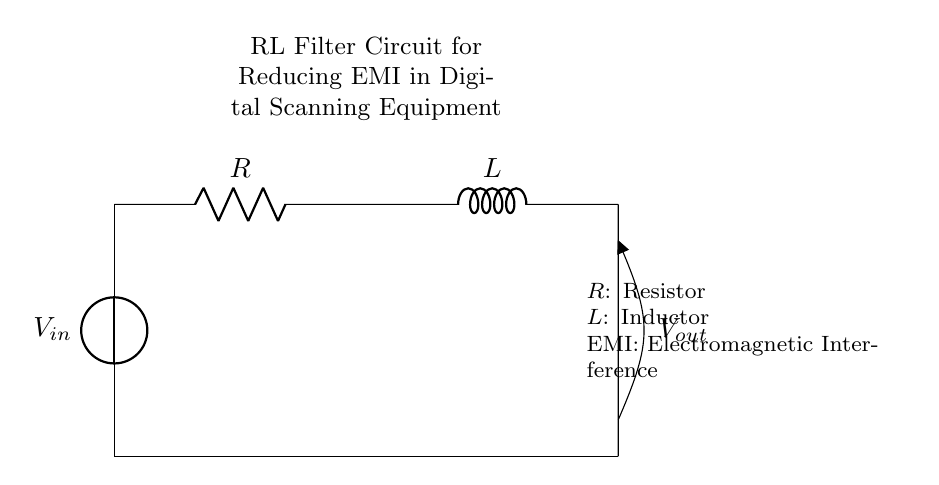What components are present in the circuit? The circuit contains a voltage source, a resistor, and an inductor. These components are essential for the operation of the RL filter.
Answer: Voltage source, resistor, inductor What is the function of the inductor in this circuit? The inductor's primary function is to oppose changes in current, thus helping to filter out high-frequency noise or electromagnetic interference.
Answer: Filter EMI What is the value of the resistance denoted in the circuit? The circuit specifies a resistor labeled as R, indicating it is the resistance component but does not provide a numerical value.
Answer: R What type of circuit is represented by the combination of components here? The combination of a resistor and an inductor in series forms an RL filter circuit, which is specifically designed for signal processing applications.
Answer: RL filter circuit How does the RL filter affect the output voltage compared to the input voltage? The RL filter attenuates high-frequency components, resulting in an output voltage that is lower than the input voltage for these frequencies.
Answer: Output voltage lower than input What happens to current in the circuit when switching occurs? When switching occurs, the inductor resists changes in current flow, causing a delay in reaching a new steady-state value, which is a fundamental property of inductors.
Answer: Delayed current change What is indicated by the voltage measurement across the output? The voltage across the output represents the filtered signal, which has reduced EMI components compared to the input voltage.
Answer: Filtered signal voltage 